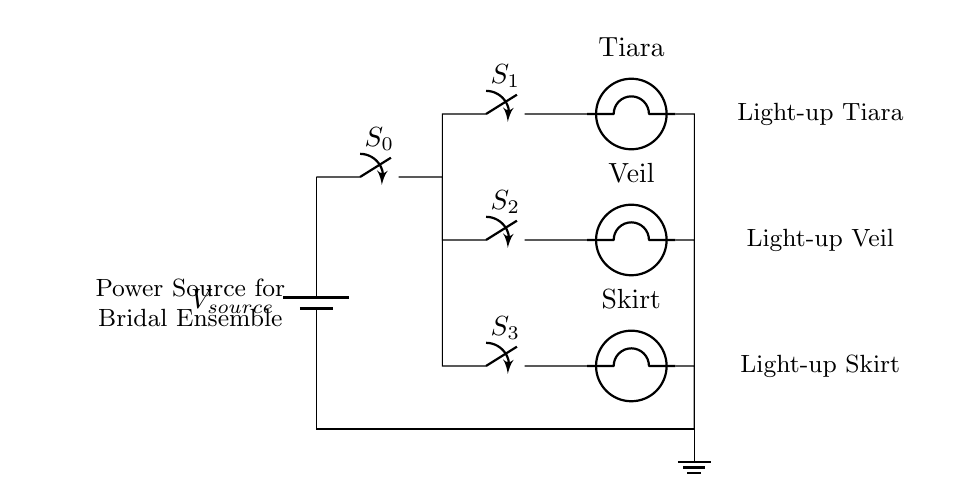What is the type of circuit represented? The circuit is a parallel circuit, where multiple switches and bulbs are connected across the same voltage sources so that they operate independently.
Answer: Parallel circuit How many switches are there in the diagram? The diagram shows a total of four switches: one main switch and three parallel switches for the accessories.
Answer: Four switches Which accessory is connected to switch S1? The accessory connected to switch S1 is the light-up Tiara, as indicated in the diagram’s labeling.
Answer: Light-up Tiara What happens when a switch is closed in this circuit? When a switch is closed, the corresponding light-up accessory connected to that switch will illuminate, as it completes the circuit for that particular branch.
Answer: Accessory illuminates If switch S2 is closed, what is the status of the other switches? The status of the other switches (S1 and S3) does not affect S2; therefore, they can remain open or closed independently without affecting the light-up Veil.
Answer: Independent status What is the role of the main switch S0 in this circuit? The main switch S0 controls the overall power flow to the entire circuit and allows or restricts voltage from reaching the parallel branches.
Answer: Power control How many light-up accessories can be activated simultaneously? All three light-up accessories can be activated simultaneously since they are connected in parallel, meaning closing any combination of their switches activates those particular accessories.
Answer: Three accessories 